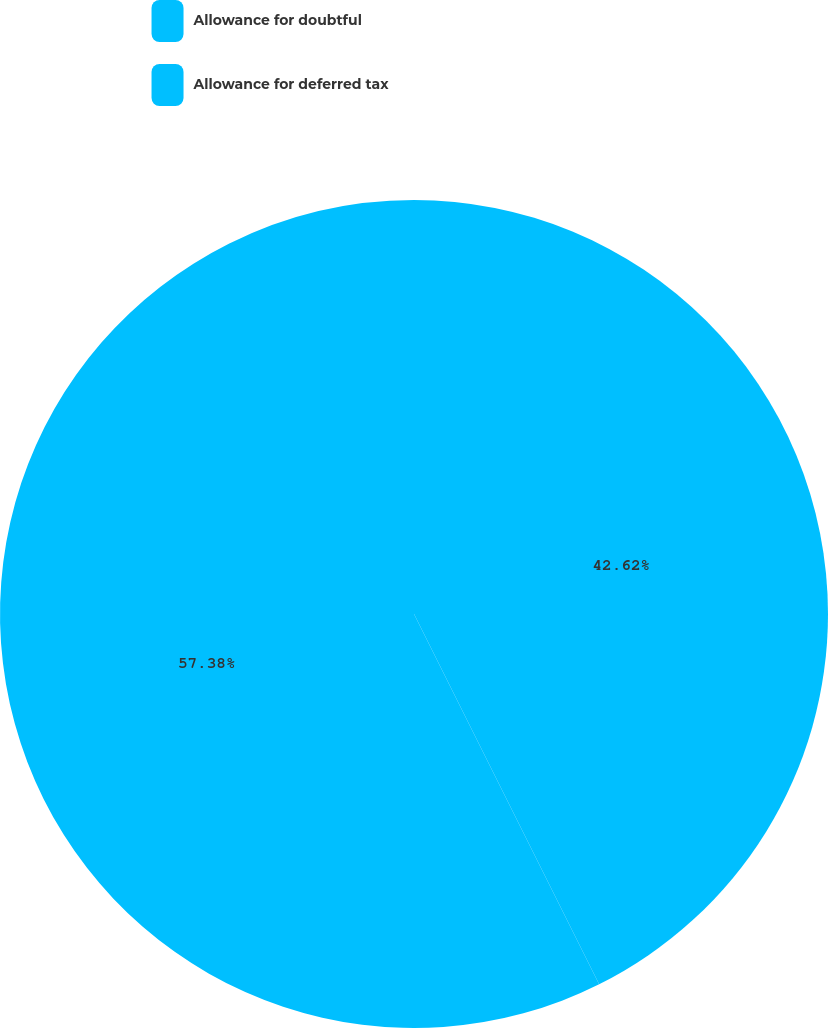Convert chart. <chart><loc_0><loc_0><loc_500><loc_500><pie_chart><fcel>Allowance for doubtful<fcel>Allowance for deferred tax<nl><fcel>42.62%<fcel>57.38%<nl></chart> 